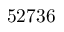Convert formula to latex. <formula><loc_0><loc_0><loc_500><loc_500>5 2 7 3 6</formula> 